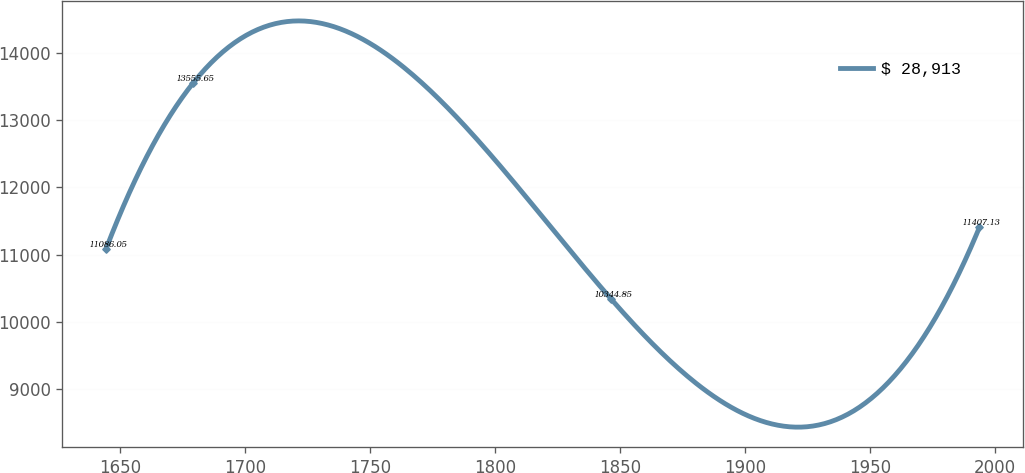Convert chart to OTSL. <chart><loc_0><loc_0><loc_500><loc_500><line_chart><ecel><fcel>$ 28,913<nl><fcel>1644.23<fcel>11086<nl><fcel>1679.17<fcel>13555.6<nl><fcel>1846.25<fcel>10344.9<nl><fcel>1993.67<fcel>11407.1<nl></chart> 